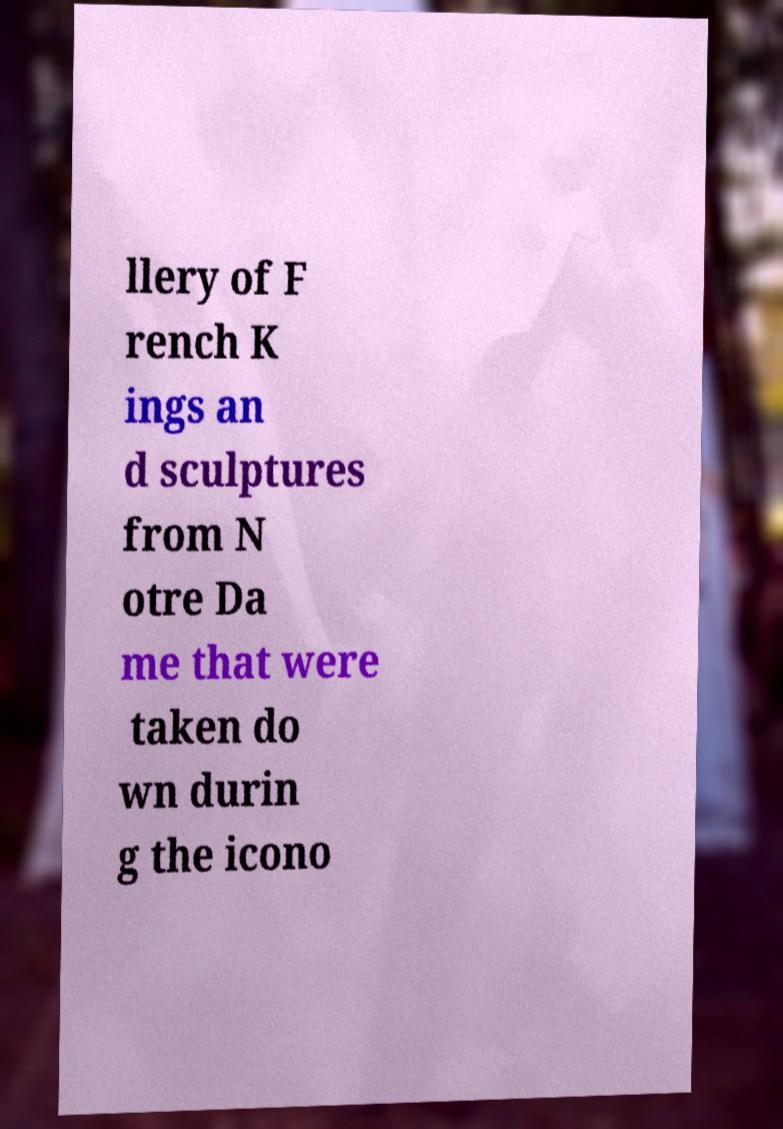Could you extract and type out the text from this image? llery of F rench K ings an d sculptures from N otre Da me that were taken do wn durin g the icono 